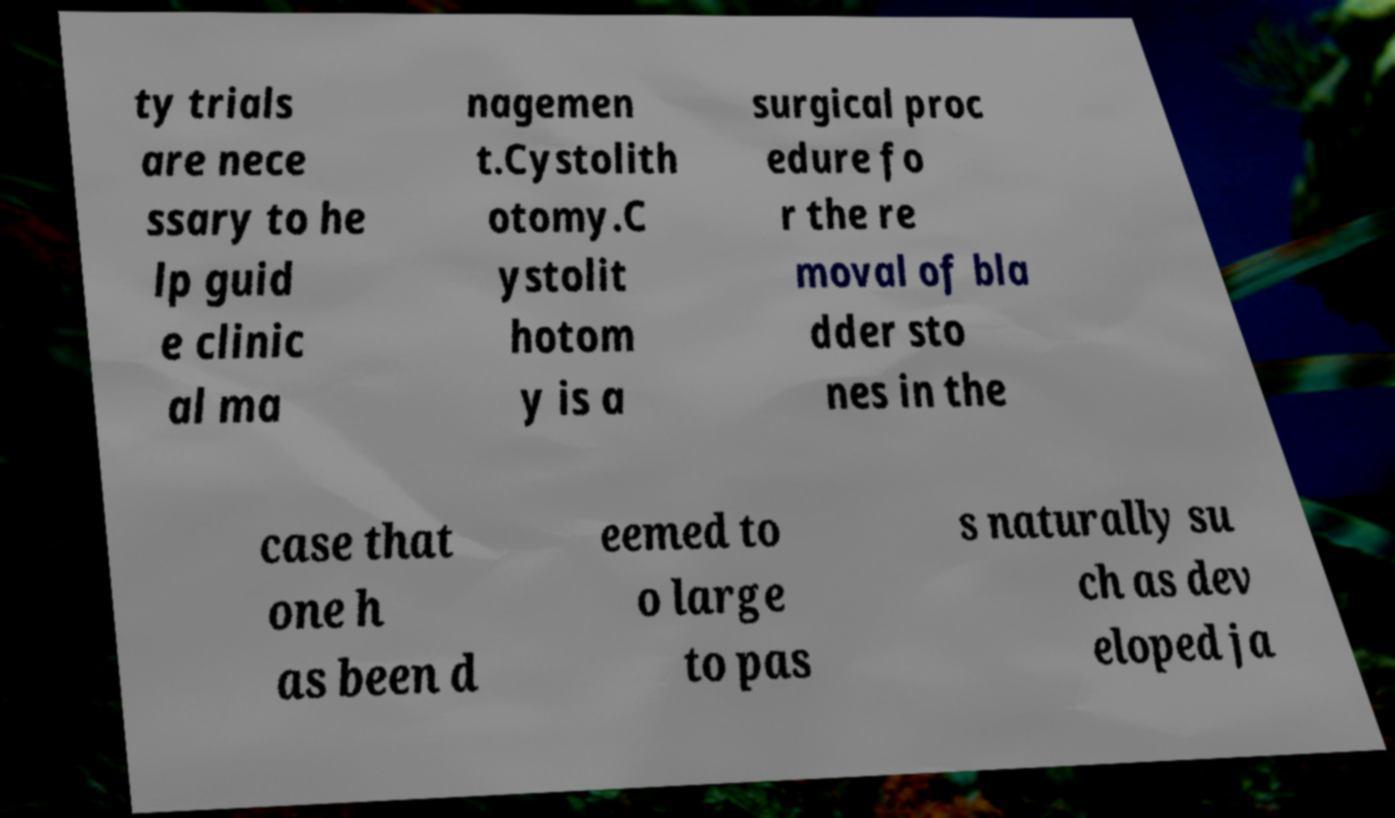There's text embedded in this image that I need extracted. Can you transcribe it verbatim? ty trials are nece ssary to he lp guid e clinic al ma nagemen t.Cystolith otomy.C ystolit hotom y is a surgical proc edure fo r the re moval of bla dder sto nes in the case that one h as been d eemed to o large to pas s naturally su ch as dev eloped ja 